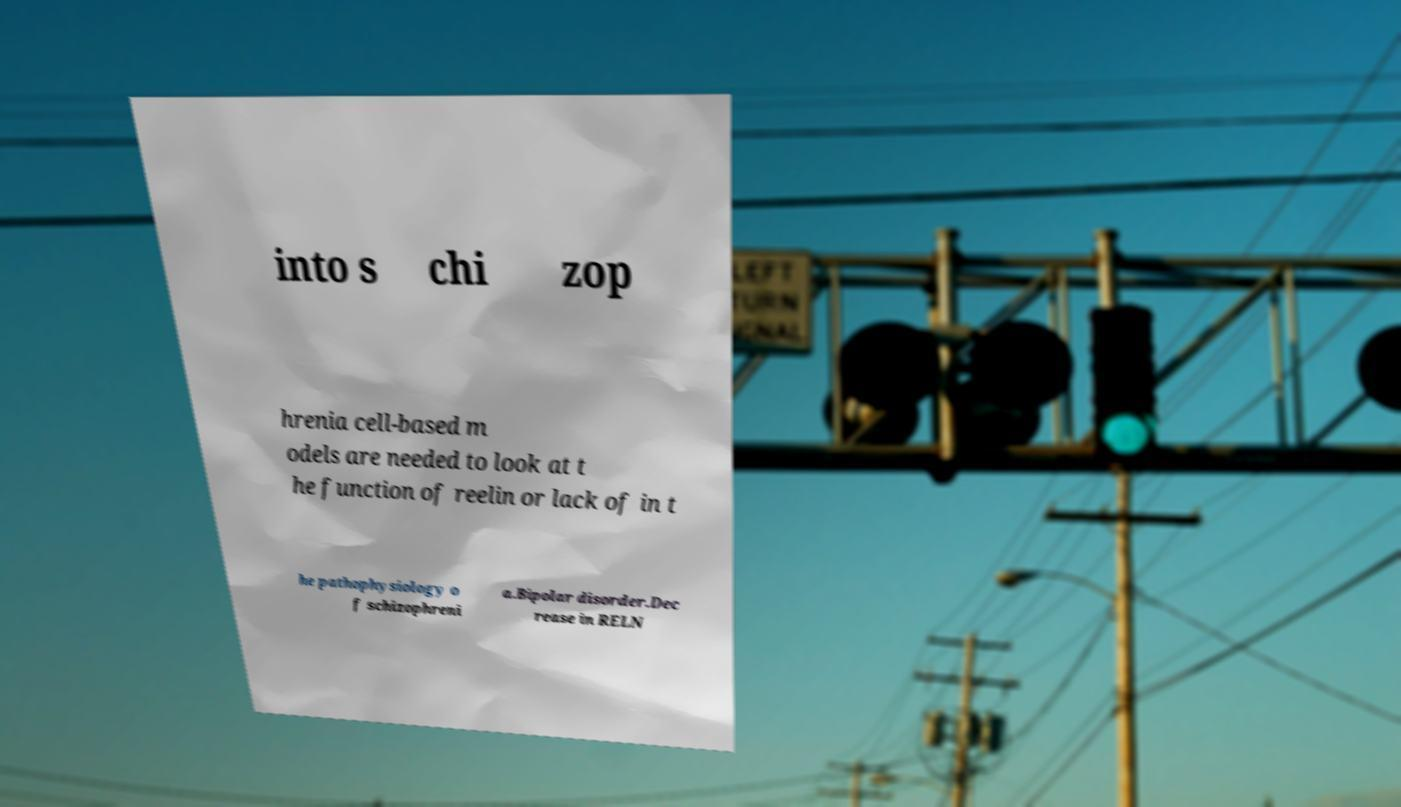Can you read and provide the text displayed in the image?This photo seems to have some interesting text. Can you extract and type it out for me? into s chi zop hrenia cell-based m odels are needed to look at t he function of reelin or lack of in t he pathophysiology o f schizophreni a.Bipolar disorder.Dec rease in RELN 